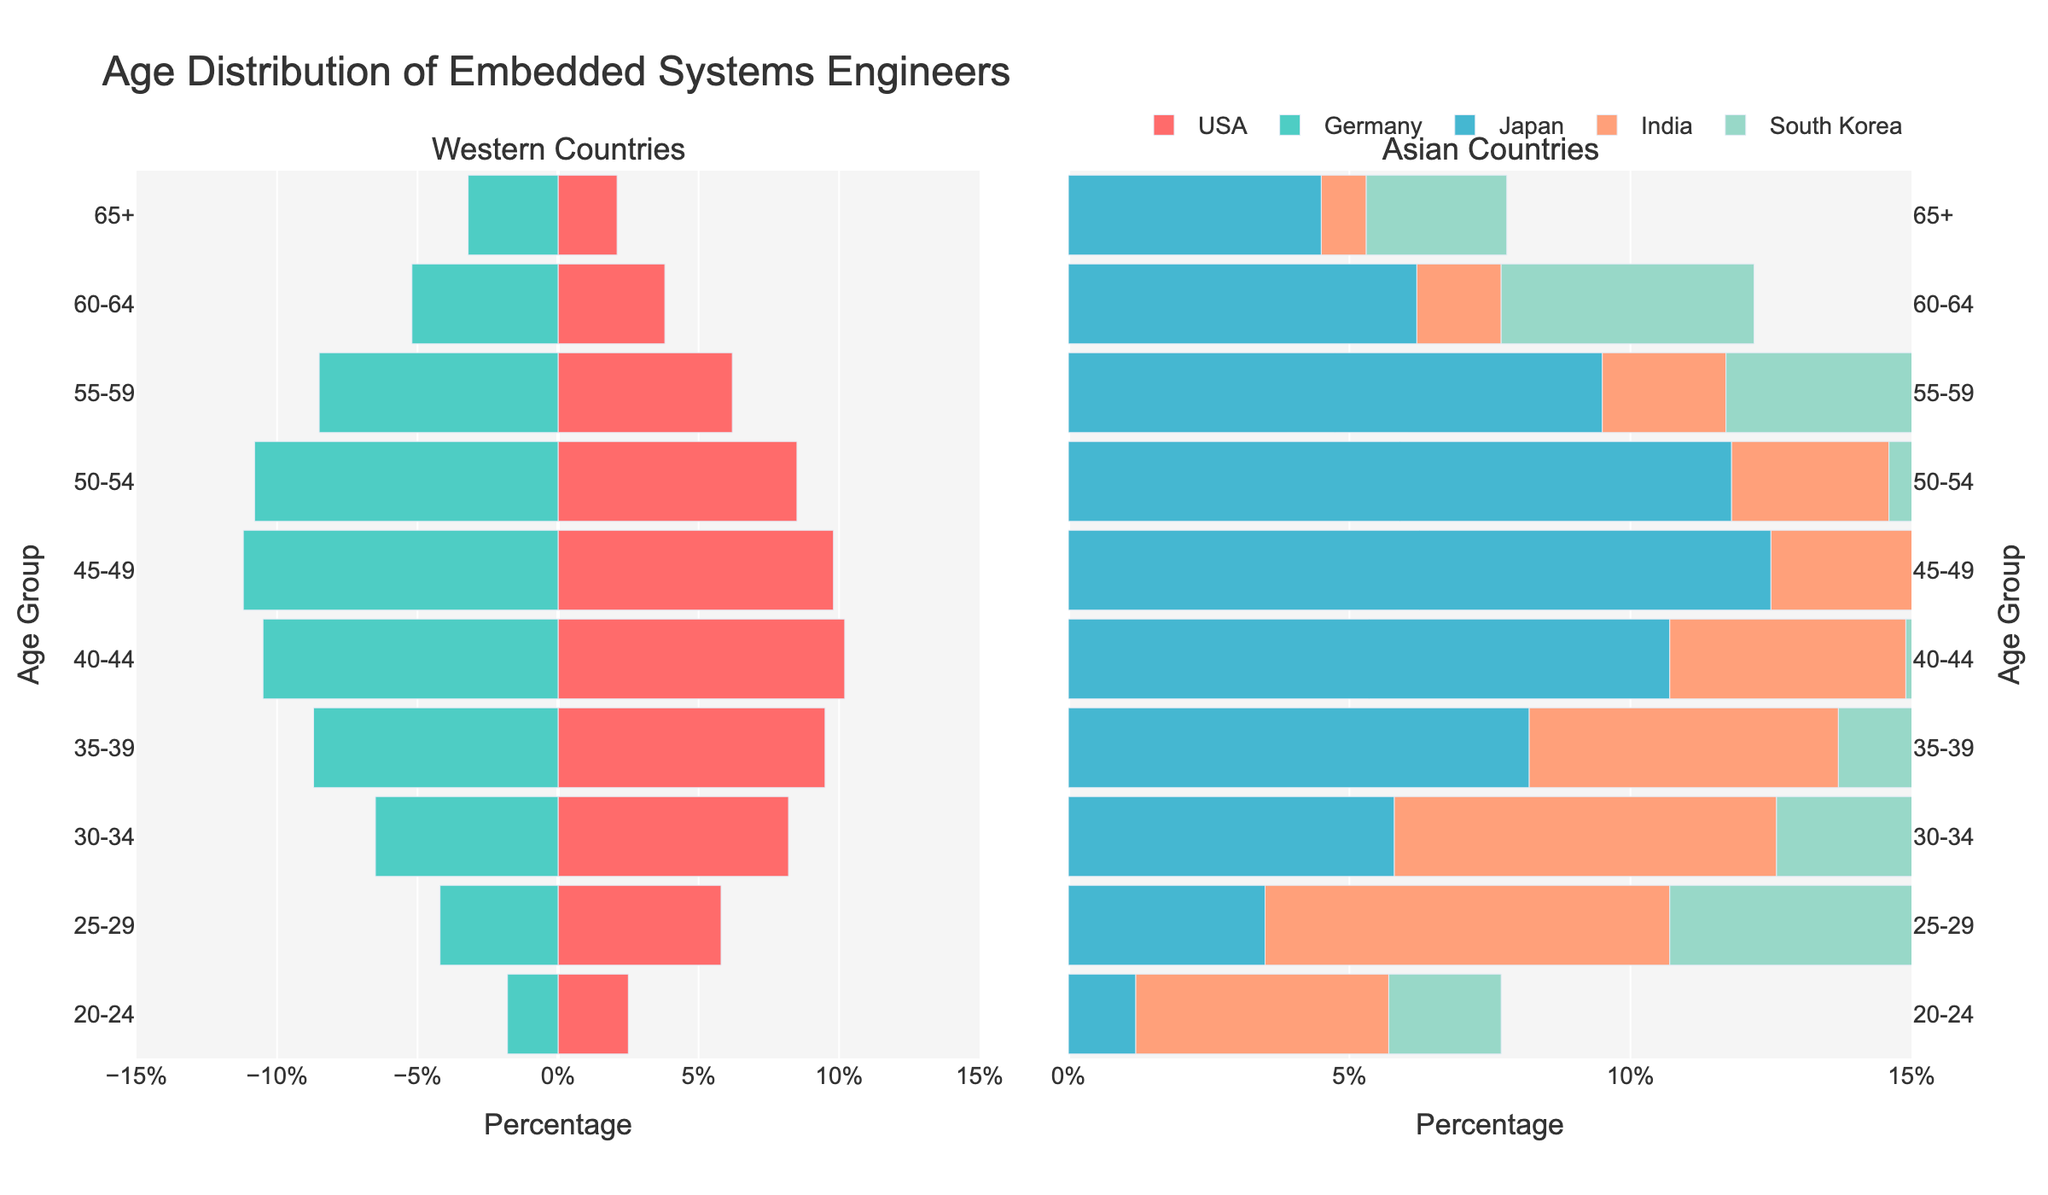Which country has the highest percentage of embedded systems engineers in the 40-44 age group? By looking at the horizontal bars for the 40-44 age group in the plot, we see that South Korea has the highest percentage.
Answer: South Korea Compare the percentage of engineers aged 25-29 in Germany and Japan. Which country has more? Comparing the horizontal bars for the 25-29 age group, Germany has a higher percentage (4.2%) than Japan (3.5%).
Answer: Germany What is the title of the figure? The title is located at the top of the figure and reads "Age Distribution of Embedded Systems Engineers".
Answer: Age Distribution of Embedded Systems Engineers Between which age groups does India have a higher percentage of engineers compared to the USA? By comparing the bars for India and the USA across all age groups, India has a higher percentage in the 20-24, 25-29, and 30-34 age groups.
Answer: 20-24, 25-29, 30-34 What is the percentage difference between the 50-54 age group of USA and South Korea? The percentage for the USA is 8.5%, and for South Korea, it is 9.8%. The difference is 9.8% - 8.5% = 1.3%.
Answer: 1.3% Which age group shows the lowest percentage of engineers in all countries combined? The 65+ age group has the lowest percentages in all countries when compared to other age groups.
Answer: 65+ How does the age distribution pattern differ between Western and Asian countries as shown in the plot? In Western countries, the percentage of embedded systems engineers tends to peak around the 40-44 age group and slightly decline afterward. In Asian countries, the peak is not as pronounced but is more spread out across multiple age groups, particularly from 30-44. There is also a higher percentage of younger engineers in India.
Answer: Western: 40-44 peak, gradual decline; Asian: spread from 30-44, higher young engineers in India What percentage of engineers aged 55-59 are from Japan? From the horizontal bar corresponding to Japan in the 55-59 age group, it shows 9.5%.
Answer: 9.5% In which subplot are the Asian countries' distributions shown? By referring to the subplot titles, the Asian countries' distributions are shown in the second subplot on the right.
Answer: Right subplot Combine the percentage of engineers aged 40-44 and 45-49 in the USA. The percentages for the 40-44 and 45-49 age groups in the USA are 10.2% and 9.8%, respectively. The combined percentage is 10.2% + 9.8% = 20%.
Answer: 20% 